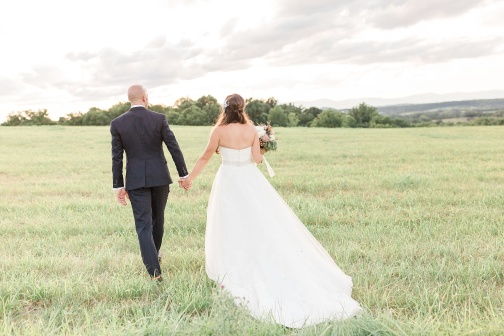Create a detailed story about this couple's day leading up to this moment. In the early hours of the morning, the day began with the soft chirps of birds and the gentle whispers of the wind. The bride, Emily, woke up with a mixture of excitement and nerves, knowing that today was her wedding day. Her friends and family surrounded her, helping her put on her elegant white dress and arrange her hair in cascading waves. Meanwhile, the groom, James, dressed in his sharp black suit, shared moments of laughter and encouragement with his closest friends. As the anticipation built, Emily and James eagerly waited for the ceremony to start. The vows were exchanged in a quaint chapel nearby, a place filled with the scent of fresh flowers and the warm smiles of loved ones. After a heartfelt ceremony and joyous celebrations, Emily and James decided to take a quiet walk through the nearby field. Hand in hand, they reveled in the beauty of the land, the vastness of the green field, and the expanse of the blue sky overhead. This image captures that moment of calm, love, and the promise of their journey ahead.  What could be the significance of the field being so lush and green in relation to the couple's journey? The lushness and greenness of the field can symbolize fertility, growth, and prosperity. For the couple, it might represent a bountiful and hopeful future, filled with opportunities to grow together in their new life. The green field embodies nature's vitality and renewal, mirroring the couple's fresh start and the potential for flourishing in their union. 